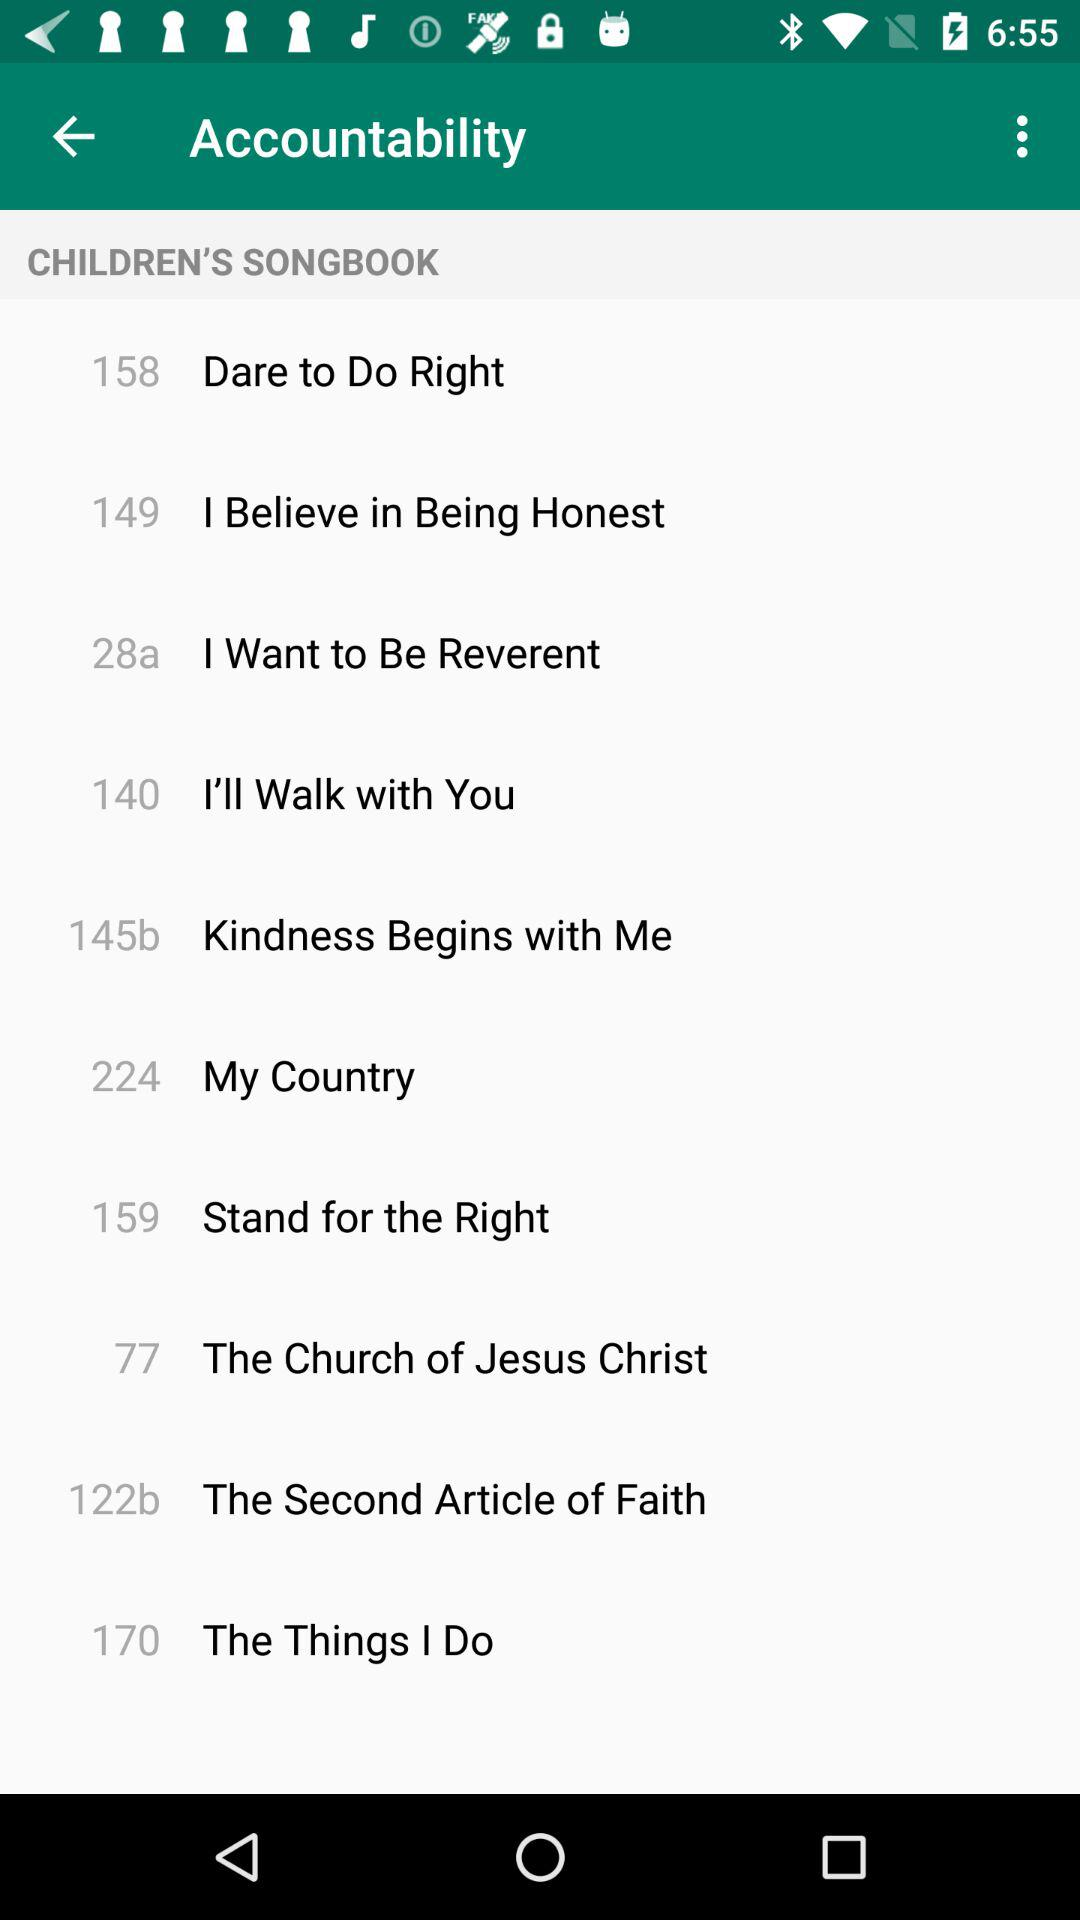What song is on page number 158? The song on page number 158 is "Dare to Do Right". 